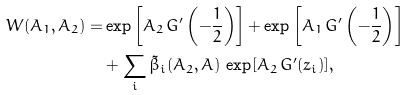<formula> <loc_0><loc_0><loc_500><loc_500>W ( A _ { 1 } , A _ { 2 } ) = & \exp \left [ A _ { 2 } \, G ^ { \prime } \left ( - \frac { 1 } { 2 } \right ) \right ] + \exp \left [ A _ { 1 } \, G ^ { \prime } \left ( - \frac { 1 } { 2 } \right ) \right ] \\ & + \sum _ { i } \tilde { \beta } _ { i } ( A _ { 2 } , A ) \, \exp [ A _ { 2 } \, G ^ { \prime } ( z _ { i } ) ] ,</formula> 